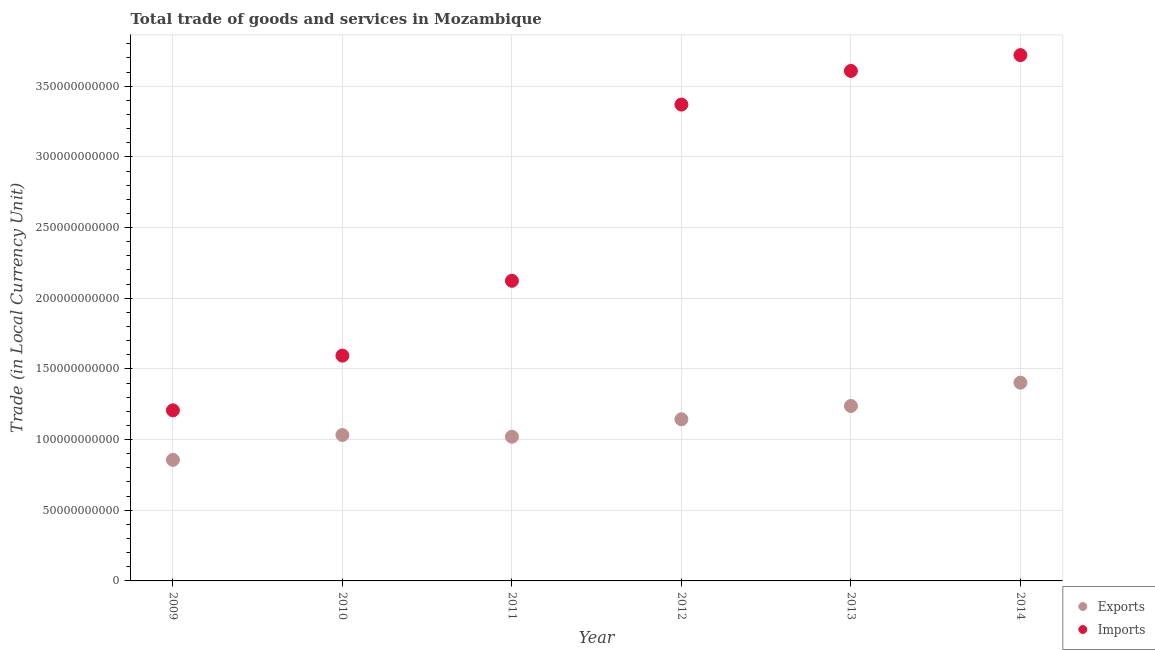Is the number of dotlines equal to the number of legend labels?
Provide a succinct answer. Yes. What is the imports of goods and services in 2012?
Ensure brevity in your answer.  3.37e+11. Across all years, what is the maximum imports of goods and services?
Your response must be concise. 3.72e+11. Across all years, what is the minimum export of goods and services?
Make the answer very short. 8.57e+1. In which year was the imports of goods and services minimum?
Your answer should be compact. 2009. What is the total imports of goods and services in the graph?
Provide a succinct answer. 1.56e+12. What is the difference between the imports of goods and services in 2012 and that in 2013?
Give a very brief answer. -2.38e+1. What is the difference between the imports of goods and services in 2011 and the export of goods and services in 2013?
Ensure brevity in your answer.  8.86e+1. What is the average imports of goods and services per year?
Make the answer very short. 2.60e+11. In the year 2014, what is the difference between the imports of goods and services and export of goods and services?
Keep it short and to the point. 2.32e+11. In how many years, is the export of goods and services greater than 190000000000 LCU?
Make the answer very short. 0. What is the ratio of the export of goods and services in 2013 to that in 2014?
Your answer should be compact. 0.88. Is the export of goods and services in 2009 less than that in 2010?
Your answer should be compact. Yes. Is the difference between the imports of goods and services in 2012 and 2013 greater than the difference between the export of goods and services in 2012 and 2013?
Make the answer very short. No. What is the difference between the highest and the second highest export of goods and services?
Offer a terse response. 1.65e+1. What is the difference between the highest and the lowest imports of goods and services?
Your answer should be very brief. 2.51e+11. Does the imports of goods and services monotonically increase over the years?
Provide a succinct answer. Yes. Is the export of goods and services strictly greater than the imports of goods and services over the years?
Make the answer very short. No. What is the difference between two consecutive major ticks on the Y-axis?
Offer a terse response. 5.00e+1. Are the values on the major ticks of Y-axis written in scientific E-notation?
Provide a succinct answer. No. Does the graph contain any zero values?
Offer a very short reply. No. Does the graph contain grids?
Offer a very short reply. Yes. Where does the legend appear in the graph?
Offer a terse response. Bottom right. How many legend labels are there?
Provide a succinct answer. 2. What is the title of the graph?
Make the answer very short. Total trade of goods and services in Mozambique. Does "Investment in Telecom" appear as one of the legend labels in the graph?
Your answer should be compact. No. What is the label or title of the X-axis?
Ensure brevity in your answer.  Year. What is the label or title of the Y-axis?
Offer a terse response. Trade (in Local Currency Unit). What is the Trade (in Local Currency Unit) in Exports in 2009?
Your response must be concise. 8.57e+1. What is the Trade (in Local Currency Unit) in Imports in 2009?
Give a very brief answer. 1.21e+11. What is the Trade (in Local Currency Unit) in Exports in 2010?
Offer a terse response. 1.03e+11. What is the Trade (in Local Currency Unit) of Imports in 2010?
Your response must be concise. 1.59e+11. What is the Trade (in Local Currency Unit) of Exports in 2011?
Your answer should be compact. 1.02e+11. What is the Trade (in Local Currency Unit) of Imports in 2011?
Ensure brevity in your answer.  2.12e+11. What is the Trade (in Local Currency Unit) in Exports in 2012?
Your answer should be compact. 1.14e+11. What is the Trade (in Local Currency Unit) in Imports in 2012?
Your answer should be compact. 3.37e+11. What is the Trade (in Local Currency Unit) of Exports in 2013?
Make the answer very short. 1.24e+11. What is the Trade (in Local Currency Unit) in Imports in 2013?
Make the answer very short. 3.61e+11. What is the Trade (in Local Currency Unit) in Exports in 2014?
Give a very brief answer. 1.40e+11. What is the Trade (in Local Currency Unit) of Imports in 2014?
Give a very brief answer. 3.72e+11. Across all years, what is the maximum Trade (in Local Currency Unit) of Exports?
Give a very brief answer. 1.40e+11. Across all years, what is the maximum Trade (in Local Currency Unit) of Imports?
Your answer should be compact. 3.72e+11. Across all years, what is the minimum Trade (in Local Currency Unit) of Exports?
Make the answer very short. 8.57e+1. Across all years, what is the minimum Trade (in Local Currency Unit) of Imports?
Keep it short and to the point. 1.21e+11. What is the total Trade (in Local Currency Unit) of Exports in the graph?
Ensure brevity in your answer.  6.69e+11. What is the total Trade (in Local Currency Unit) in Imports in the graph?
Your answer should be very brief. 1.56e+12. What is the difference between the Trade (in Local Currency Unit) in Exports in 2009 and that in 2010?
Make the answer very short. -1.76e+1. What is the difference between the Trade (in Local Currency Unit) of Imports in 2009 and that in 2010?
Give a very brief answer. -3.87e+1. What is the difference between the Trade (in Local Currency Unit) of Exports in 2009 and that in 2011?
Offer a terse response. -1.64e+1. What is the difference between the Trade (in Local Currency Unit) of Imports in 2009 and that in 2011?
Make the answer very short. -9.16e+1. What is the difference between the Trade (in Local Currency Unit) in Exports in 2009 and that in 2012?
Your answer should be compact. -2.87e+1. What is the difference between the Trade (in Local Currency Unit) of Imports in 2009 and that in 2012?
Provide a short and direct response. -2.16e+11. What is the difference between the Trade (in Local Currency Unit) of Exports in 2009 and that in 2013?
Make the answer very short. -3.81e+1. What is the difference between the Trade (in Local Currency Unit) of Imports in 2009 and that in 2013?
Provide a succinct answer. -2.40e+11. What is the difference between the Trade (in Local Currency Unit) of Exports in 2009 and that in 2014?
Offer a terse response. -5.46e+1. What is the difference between the Trade (in Local Currency Unit) in Imports in 2009 and that in 2014?
Give a very brief answer. -2.51e+11. What is the difference between the Trade (in Local Currency Unit) of Exports in 2010 and that in 2011?
Offer a very short reply. 1.23e+09. What is the difference between the Trade (in Local Currency Unit) of Imports in 2010 and that in 2011?
Ensure brevity in your answer.  -5.30e+1. What is the difference between the Trade (in Local Currency Unit) of Exports in 2010 and that in 2012?
Keep it short and to the point. -1.11e+1. What is the difference between the Trade (in Local Currency Unit) of Imports in 2010 and that in 2012?
Keep it short and to the point. -1.78e+11. What is the difference between the Trade (in Local Currency Unit) in Exports in 2010 and that in 2013?
Offer a very short reply. -2.05e+1. What is the difference between the Trade (in Local Currency Unit) in Imports in 2010 and that in 2013?
Provide a short and direct response. -2.01e+11. What is the difference between the Trade (in Local Currency Unit) of Exports in 2010 and that in 2014?
Make the answer very short. -3.70e+1. What is the difference between the Trade (in Local Currency Unit) of Imports in 2010 and that in 2014?
Provide a succinct answer. -2.13e+11. What is the difference between the Trade (in Local Currency Unit) in Exports in 2011 and that in 2012?
Provide a succinct answer. -1.24e+1. What is the difference between the Trade (in Local Currency Unit) of Imports in 2011 and that in 2012?
Keep it short and to the point. -1.25e+11. What is the difference between the Trade (in Local Currency Unit) in Exports in 2011 and that in 2013?
Your answer should be compact. -2.17e+1. What is the difference between the Trade (in Local Currency Unit) of Imports in 2011 and that in 2013?
Give a very brief answer. -1.49e+11. What is the difference between the Trade (in Local Currency Unit) in Exports in 2011 and that in 2014?
Provide a short and direct response. -3.82e+1. What is the difference between the Trade (in Local Currency Unit) of Imports in 2011 and that in 2014?
Ensure brevity in your answer.  -1.60e+11. What is the difference between the Trade (in Local Currency Unit) in Exports in 2012 and that in 2013?
Make the answer very short. -9.38e+09. What is the difference between the Trade (in Local Currency Unit) of Imports in 2012 and that in 2013?
Provide a short and direct response. -2.38e+1. What is the difference between the Trade (in Local Currency Unit) of Exports in 2012 and that in 2014?
Your answer should be compact. -2.59e+1. What is the difference between the Trade (in Local Currency Unit) in Imports in 2012 and that in 2014?
Your answer should be very brief. -3.50e+1. What is the difference between the Trade (in Local Currency Unit) in Exports in 2013 and that in 2014?
Provide a succinct answer. -1.65e+1. What is the difference between the Trade (in Local Currency Unit) of Imports in 2013 and that in 2014?
Your response must be concise. -1.12e+1. What is the difference between the Trade (in Local Currency Unit) of Exports in 2009 and the Trade (in Local Currency Unit) of Imports in 2010?
Your answer should be very brief. -7.37e+1. What is the difference between the Trade (in Local Currency Unit) of Exports in 2009 and the Trade (in Local Currency Unit) of Imports in 2011?
Make the answer very short. -1.27e+11. What is the difference between the Trade (in Local Currency Unit) in Exports in 2009 and the Trade (in Local Currency Unit) in Imports in 2012?
Keep it short and to the point. -2.51e+11. What is the difference between the Trade (in Local Currency Unit) in Exports in 2009 and the Trade (in Local Currency Unit) in Imports in 2013?
Offer a terse response. -2.75e+11. What is the difference between the Trade (in Local Currency Unit) in Exports in 2009 and the Trade (in Local Currency Unit) in Imports in 2014?
Provide a succinct answer. -2.86e+11. What is the difference between the Trade (in Local Currency Unit) in Exports in 2010 and the Trade (in Local Currency Unit) in Imports in 2011?
Give a very brief answer. -1.09e+11. What is the difference between the Trade (in Local Currency Unit) of Exports in 2010 and the Trade (in Local Currency Unit) of Imports in 2012?
Provide a short and direct response. -2.34e+11. What is the difference between the Trade (in Local Currency Unit) of Exports in 2010 and the Trade (in Local Currency Unit) of Imports in 2013?
Your answer should be compact. -2.58e+11. What is the difference between the Trade (in Local Currency Unit) in Exports in 2010 and the Trade (in Local Currency Unit) in Imports in 2014?
Your answer should be very brief. -2.69e+11. What is the difference between the Trade (in Local Currency Unit) in Exports in 2011 and the Trade (in Local Currency Unit) in Imports in 2012?
Give a very brief answer. -2.35e+11. What is the difference between the Trade (in Local Currency Unit) of Exports in 2011 and the Trade (in Local Currency Unit) of Imports in 2013?
Your answer should be very brief. -2.59e+11. What is the difference between the Trade (in Local Currency Unit) of Exports in 2011 and the Trade (in Local Currency Unit) of Imports in 2014?
Make the answer very short. -2.70e+11. What is the difference between the Trade (in Local Currency Unit) of Exports in 2012 and the Trade (in Local Currency Unit) of Imports in 2013?
Ensure brevity in your answer.  -2.46e+11. What is the difference between the Trade (in Local Currency Unit) of Exports in 2012 and the Trade (in Local Currency Unit) of Imports in 2014?
Offer a very short reply. -2.58e+11. What is the difference between the Trade (in Local Currency Unit) of Exports in 2013 and the Trade (in Local Currency Unit) of Imports in 2014?
Provide a succinct answer. -2.48e+11. What is the average Trade (in Local Currency Unit) of Exports per year?
Provide a short and direct response. 1.12e+11. What is the average Trade (in Local Currency Unit) of Imports per year?
Provide a short and direct response. 2.60e+11. In the year 2009, what is the difference between the Trade (in Local Currency Unit) in Exports and Trade (in Local Currency Unit) in Imports?
Provide a short and direct response. -3.50e+1. In the year 2010, what is the difference between the Trade (in Local Currency Unit) of Exports and Trade (in Local Currency Unit) of Imports?
Your response must be concise. -5.61e+1. In the year 2011, what is the difference between the Trade (in Local Currency Unit) in Exports and Trade (in Local Currency Unit) in Imports?
Ensure brevity in your answer.  -1.10e+11. In the year 2012, what is the difference between the Trade (in Local Currency Unit) of Exports and Trade (in Local Currency Unit) of Imports?
Ensure brevity in your answer.  -2.23e+11. In the year 2013, what is the difference between the Trade (in Local Currency Unit) in Exports and Trade (in Local Currency Unit) in Imports?
Offer a very short reply. -2.37e+11. In the year 2014, what is the difference between the Trade (in Local Currency Unit) in Exports and Trade (in Local Currency Unit) in Imports?
Provide a short and direct response. -2.32e+11. What is the ratio of the Trade (in Local Currency Unit) of Exports in 2009 to that in 2010?
Keep it short and to the point. 0.83. What is the ratio of the Trade (in Local Currency Unit) in Imports in 2009 to that in 2010?
Give a very brief answer. 0.76. What is the ratio of the Trade (in Local Currency Unit) of Exports in 2009 to that in 2011?
Offer a terse response. 0.84. What is the ratio of the Trade (in Local Currency Unit) in Imports in 2009 to that in 2011?
Ensure brevity in your answer.  0.57. What is the ratio of the Trade (in Local Currency Unit) of Exports in 2009 to that in 2012?
Offer a very short reply. 0.75. What is the ratio of the Trade (in Local Currency Unit) of Imports in 2009 to that in 2012?
Your response must be concise. 0.36. What is the ratio of the Trade (in Local Currency Unit) in Exports in 2009 to that in 2013?
Give a very brief answer. 0.69. What is the ratio of the Trade (in Local Currency Unit) in Imports in 2009 to that in 2013?
Ensure brevity in your answer.  0.33. What is the ratio of the Trade (in Local Currency Unit) of Exports in 2009 to that in 2014?
Offer a very short reply. 0.61. What is the ratio of the Trade (in Local Currency Unit) of Imports in 2009 to that in 2014?
Offer a terse response. 0.32. What is the ratio of the Trade (in Local Currency Unit) of Imports in 2010 to that in 2011?
Provide a short and direct response. 0.75. What is the ratio of the Trade (in Local Currency Unit) in Exports in 2010 to that in 2012?
Offer a very short reply. 0.9. What is the ratio of the Trade (in Local Currency Unit) in Imports in 2010 to that in 2012?
Ensure brevity in your answer.  0.47. What is the ratio of the Trade (in Local Currency Unit) in Exports in 2010 to that in 2013?
Your answer should be compact. 0.83. What is the ratio of the Trade (in Local Currency Unit) of Imports in 2010 to that in 2013?
Offer a terse response. 0.44. What is the ratio of the Trade (in Local Currency Unit) in Exports in 2010 to that in 2014?
Your answer should be compact. 0.74. What is the ratio of the Trade (in Local Currency Unit) in Imports in 2010 to that in 2014?
Provide a succinct answer. 0.43. What is the ratio of the Trade (in Local Currency Unit) in Exports in 2011 to that in 2012?
Keep it short and to the point. 0.89. What is the ratio of the Trade (in Local Currency Unit) in Imports in 2011 to that in 2012?
Ensure brevity in your answer.  0.63. What is the ratio of the Trade (in Local Currency Unit) in Exports in 2011 to that in 2013?
Keep it short and to the point. 0.82. What is the ratio of the Trade (in Local Currency Unit) of Imports in 2011 to that in 2013?
Keep it short and to the point. 0.59. What is the ratio of the Trade (in Local Currency Unit) in Exports in 2011 to that in 2014?
Your answer should be very brief. 0.73. What is the ratio of the Trade (in Local Currency Unit) in Imports in 2011 to that in 2014?
Provide a short and direct response. 0.57. What is the ratio of the Trade (in Local Currency Unit) in Exports in 2012 to that in 2013?
Offer a terse response. 0.92. What is the ratio of the Trade (in Local Currency Unit) of Imports in 2012 to that in 2013?
Provide a short and direct response. 0.93. What is the ratio of the Trade (in Local Currency Unit) of Exports in 2012 to that in 2014?
Provide a succinct answer. 0.82. What is the ratio of the Trade (in Local Currency Unit) of Imports in 2012 to that in 2014?
Your response must be concise. 0.91. What is the ratio of the Trade (in Local Currency Unit) in Exports in 2013 to that in 2014?
Your response must be concise. 0.88. What is the ratio of the Trade (in Local Currency Unit) in Imports in 2013 to that in 2014?
Provide a succinct answer. 0.97. What is the difference between the highest and the second highest Trade (in Local Currency Unit) of Exports?
Keep it short and to the point. 1.65e+1. What is the difference between the highest and the second highest Trade (in Local Currency Unit) in Imports?
Provide a succinct answer. 1.12e+1. What is the difference between the highest and the lowest Trade (in Local Currency Unit) in Exports?
Your answer should be compact. 5.46e+1. What is the difference between the highest and the lowest Trade (in Local Currency Unit) of Imports?
Offer a terse response. 2.51e+11. 